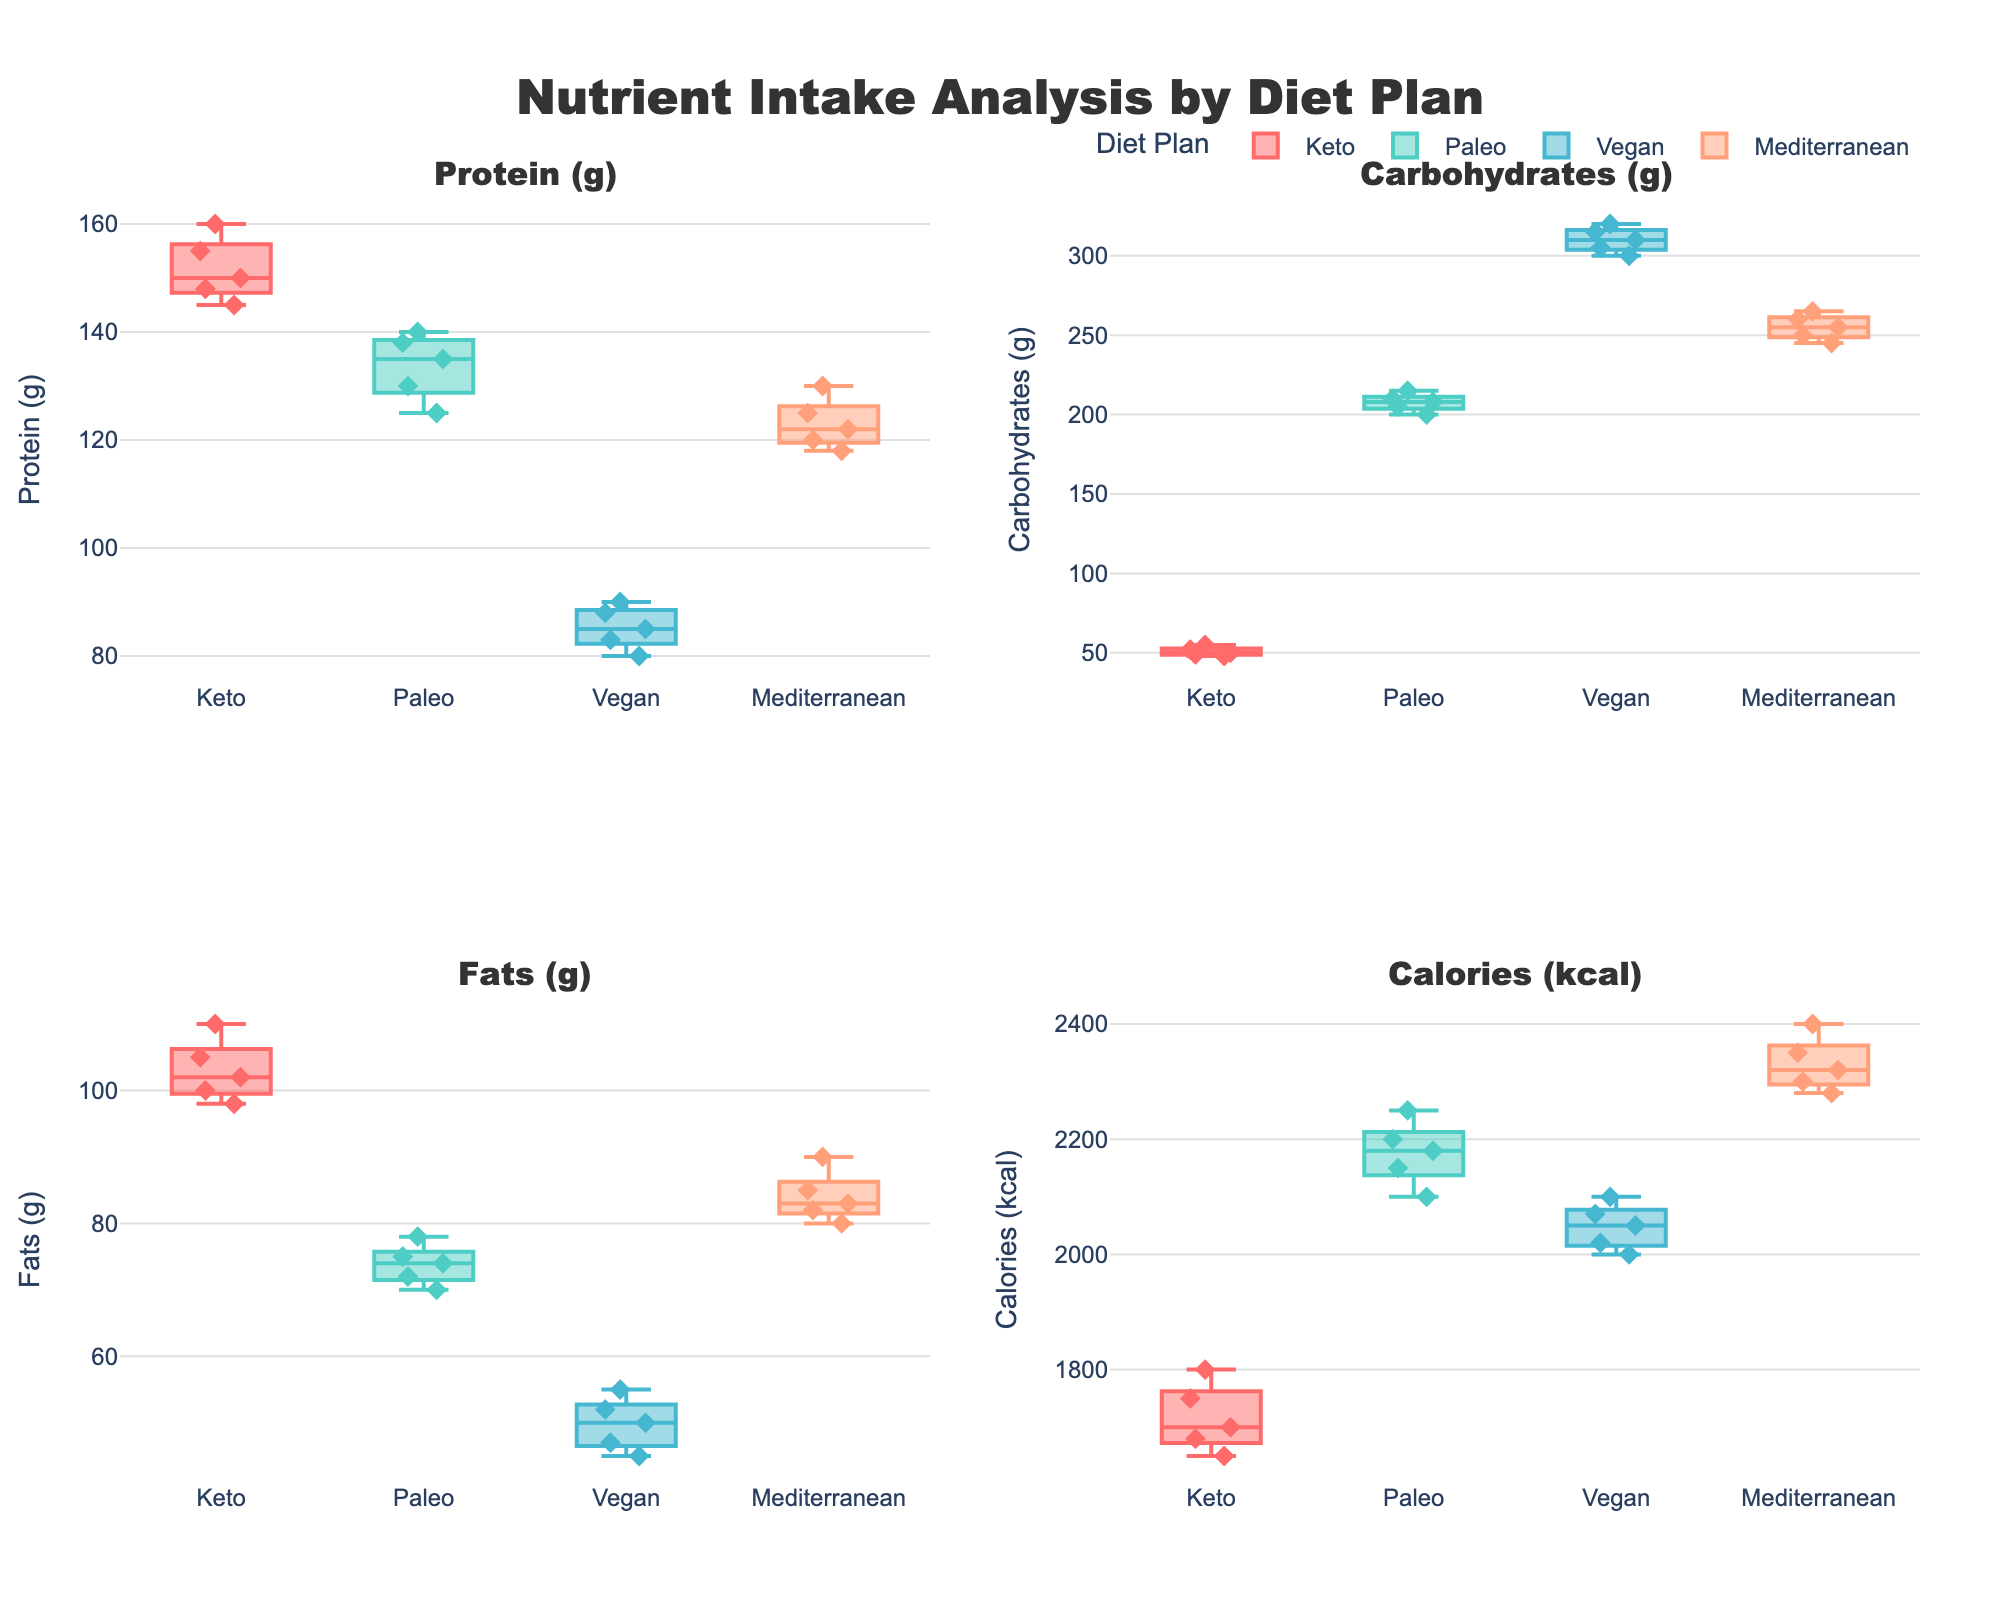What's the title of the figure? The title is prominent at the top of the figure. It reads "Nutrient Intake Analysis by Diet Plan." This is typically placed in a larger font to stand out.
Answer: Nutrient Intake Analysis by Diet Plan What's the axis title for the first subplot (top-left)? The first subplot displays data about Protein intake, indicated by the axis title clearly labeled as "Protein (g)." You can see this title on the y-axis of the subplot.
Answer: Protein (g) Which diet plan has the widest range for Protein? Look at the distribution of Protein intake in each diet. Keto has the widest range as its boxplot shows the largest spread from the minimum to the maximum values.
Answer: Keto Which diet plan shows the lowest median value for Carbohydrates? Observe the median lines within each of the Carbohydrates box plots. The Keto diet has the lowest median value among them.
Answer: Keto Which diet plan has the most data points visible on the Fats subplot? Each box plot has data points, but you can visually count the points to see that the Keto and Vegan diets both have 5 points plotted for Fats.
Answer: Keto and Vegan Between Paleo and Mediterranean diets, which one has higher median Calories? Compare the medians by looking at the lines inside the boxes for Calories intake between Paleo and Mediterranean diet plans. The Mediterranean diet has a higher median value.
Answer: Mediterranean Is the variation in Calories greater for the Vegan diet or the Mediterranean diet? Check the range from the bottom whisker to the top whisker in the Calories subplot. The range (and thus the variation) is larger for the Mediterranean diet compared to the Vegan diet.
Answer: Mediterranean How does the median Carbohydrates intake of the Paleo diet compare to the Vegan diet? Look at the median lines within the Carbohydrates box plots for both Paleo and Vegan diets. The Paleo diet has a lower median compared to the Vegan diet.
Answer: Lower Which nutrient shows the smallest variation for the Keto diet? Look at the box plots of the Keto diet across all four nutrients. The smallest box indicates the least variation, which is for Carbohydrates.
Answer: Carbohydrates What is the interquartile range (IQR) for Protein in the Mediterranean diet? The IQR is the range between the first quartile (Q1) and the third quartile (Q3). For the Mediterranean diet's Protein subplot, visually estimate the distance between the bottom and top edges of the box. The box appears to span from around 120 to 125 in Protein value.
Answer: 5 